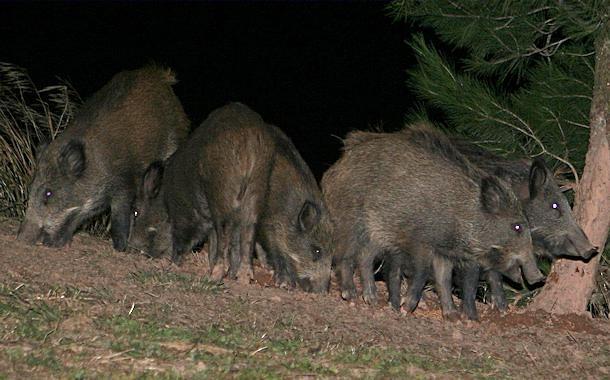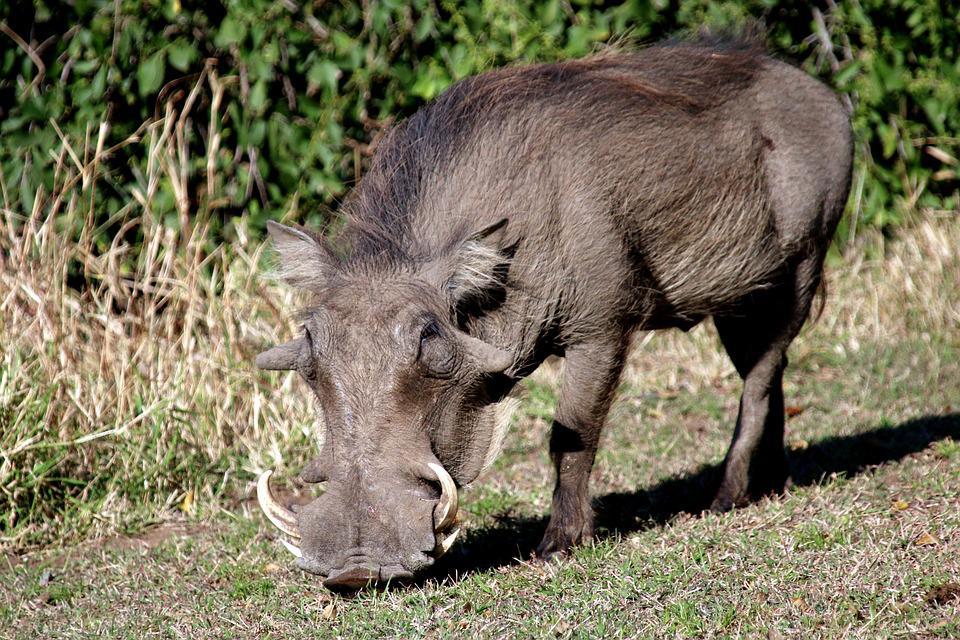The first image is the image on the left, the second image is the image on the right. Given the left and right images, does the statement "An image contains no more than two warthogs, which face forward." hold true? Answer yes or no. Yes. 